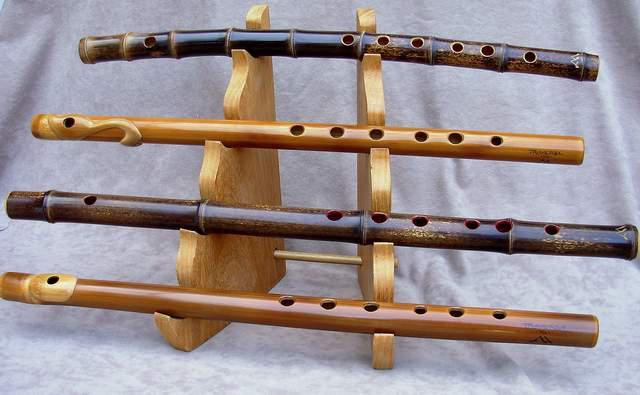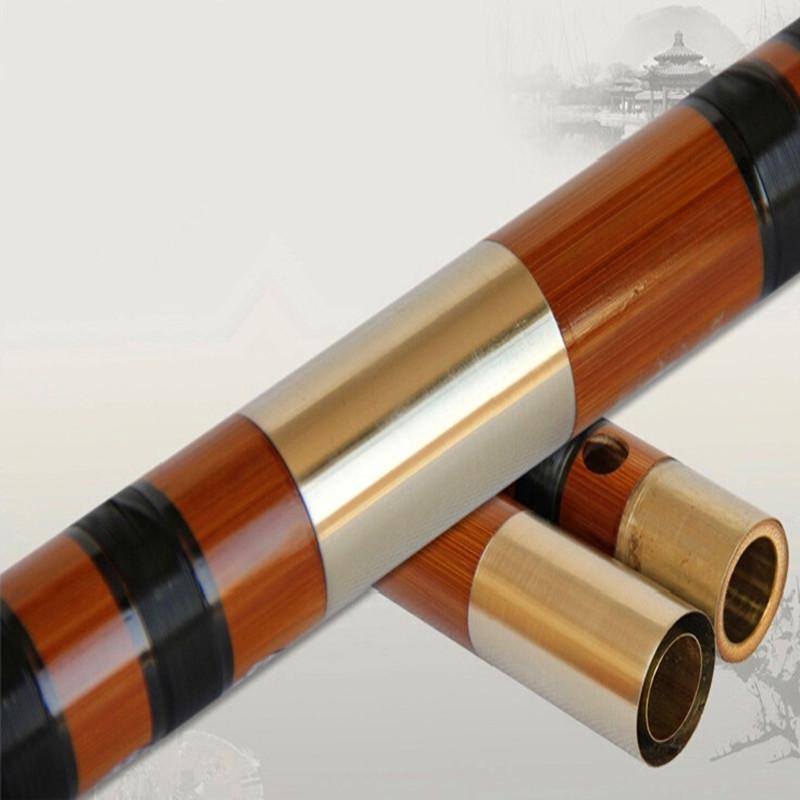The first image is the image on the left, the second image is the image on the right. For the images shown, is this caption "A human is touching a flute in one of the images." true? Answer yes or no. No. The first image is the image on the left, the second image is the image on the right. For the images displayed, is the sentence "There are at least five futes." factually correct? Answer yes or no. Yes. 